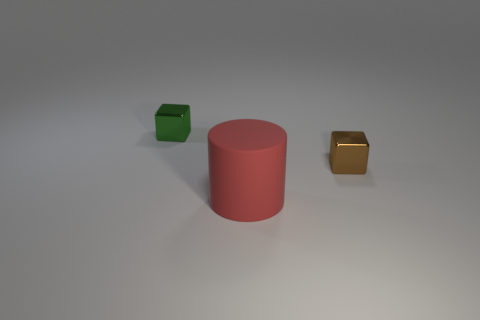What is the material of the brown object?
Provide a succinct answer. Metal. Is there any other thing that has the same size as the cylinder?
Your answer should be compact. No. There is another metallic thing that is the same shape as the small green object; what is its size?
Offer a terse response. Small. Is there a red rubber thing that is to the left of the small block right of the big red thing?
Your answer should be compact. Yes. How many other objects are there of the same shape as the tiny green object?
Offer a very short reply. 1. Is the number of large rubber cylinders that are in front of the tiny green cube greater than the number of matte cylinders that are behind the large red rubber object?
Keep it short and to the point. Yes. Does the brown thing that is to the right of the red object have the same size as the shiny object left of the large matte thing?
Your answer should be compact. Yes. What is the shape of the big red thing?
Ensure brevity in your answer.  Cylinder. What color is the other object that is made of the same material as the tiny green object?
Your answer should be compact. Brown. Is the material of the large red cylinder the same as the block on the left side of the big rubber thing?
Your response must be concise. No. 